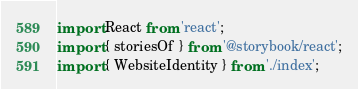<code> <loc_0><loc_0><loc_500><loc_500><_TypeScript_>import React from 'react';
import { storiesOf } from '@storybook/react';
import { WebsiteIdentity } from './index';
</code> 